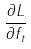<formula> <loc_0><loc_0><loc_500><loc_500>\frac { \partial L } { \partial f _ { t } }</formula> 